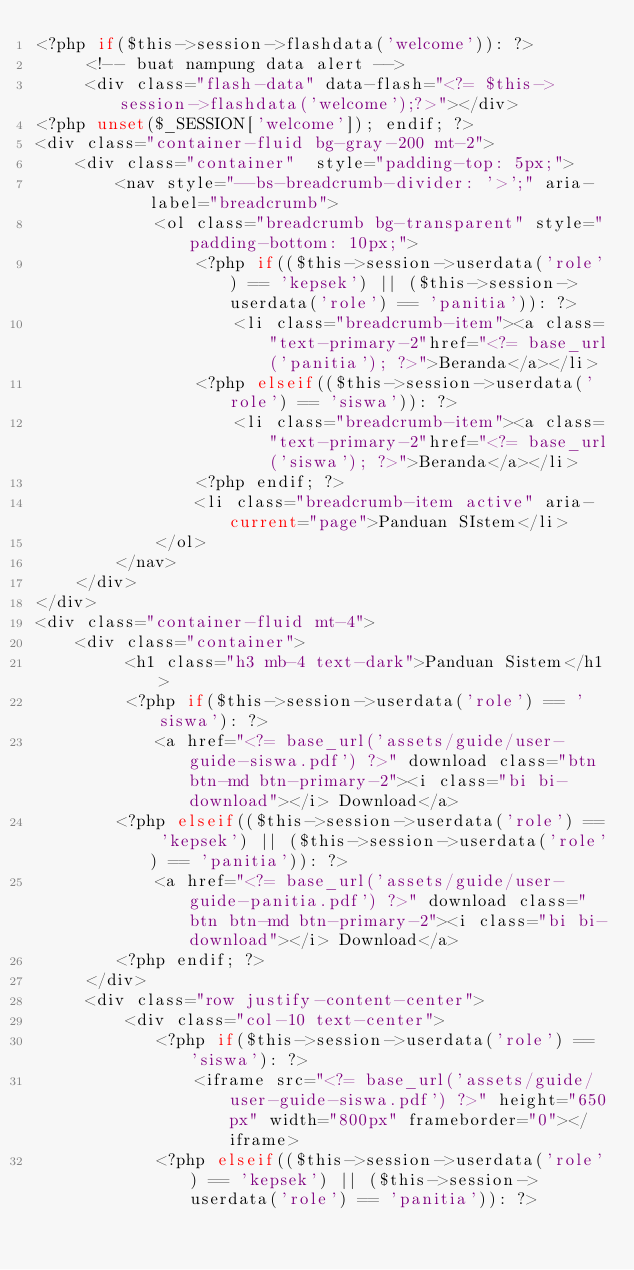Convert code to text. <code><loc_0><loc_0><loc_500><loc_500><_PHP_><?php if($this->session->flashdata('welcome')): ?>
	 <!-- buat nampung data alert -->
	 <div class="flash-data" data-flash="<?= $this->session->flashdata('welcome');?>"></div>
<?php unset($_SESSION['welcome']); endif; ?>
<div class="container-fluid bg-gray-200 mt-2">
	<div class="container"  style="padding-top: 5px;">
		<nav style="--bs-breadcrumb-divider: '>';" aria-label="breadcrumb">
			<ol class="breadcrumb bg-transparent" style="padding-bottom: 10px;">
				<?php if(($this->session->userdata('role') == 'kepsek') || ($this->session->userdata('role') == 'panitia')): ?>
					<li class="breadcrumb-item"><a class="text-primary-2"href="<?= base_url('panitia'); ?>">Beranda</a></li>
				<?php elseif(($this->session->userdata('role') == 'siswa')): ?>
					<li class="breadcrumb-item"><a class="text-primary-2"href="<?= base_url('siswa'); ?>">Beranda</a></li>
				<?php endif; ?>
				<li class="breadcrumb-item active" aria-current="page">Panduan SIstem</li>
			</ol>
		</nav>
	</div>
</div>
<div class="container-fluid mt-4">
	<div class="container">
		 <h1 class="h3 mb-4 text-dark">Panduan Sistem</h1>
		 <?php if($this->session->userdata('role') == 'siswa'): ?>
			<a href="<?= base_url('assets/guide/user-guide-siswa.pdf') ?>" download class="btn btn-md btn-primary-2"><i class="bi bi-download"></i> Download</a>
		<?php elseif(($this->session->userdata('role') == 'kepsek') || ($this->session->userdata('role') == 'panitia')): ?>
			<a href="<?= base_url('assets/guide/user-guide-panitia.pdf') ?>" download class="btn btn-md btn-primary-2"><i class="bi bi-download"></i> Download</a>
		<?php endif; ?>
	 </div>
	 <div class="row justify-content-center">
		 <div class="col-10 text-center">
			<?php if($this->session->userdata('role') == 'siswa'): ?>
			 	<iframe src="<?= base_url('assets/guide/user-guide-siswa.pdf') ?>" height="650px" width="800px" frameborder="0"></iframe>
			<?php elseif(($this->session->userdata('role') == 'kepsek') || ($this->session->userdata('role') == 'panitia')): ?></code> 